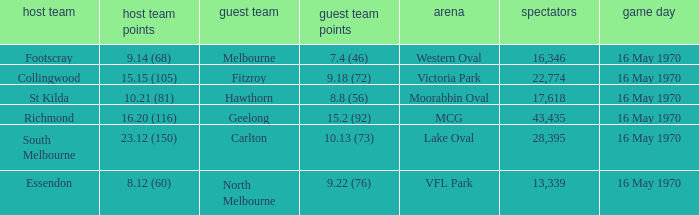What's the venue for the home team that scored 9.14 (68)? Western Oval. 